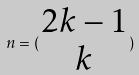Convert formula to latex. <formula><loc_0><loc_0><loc_500><loc_500>n = ( \begin{matrix} 2 k - 1 \\ k \end{matrix} )</formula> 